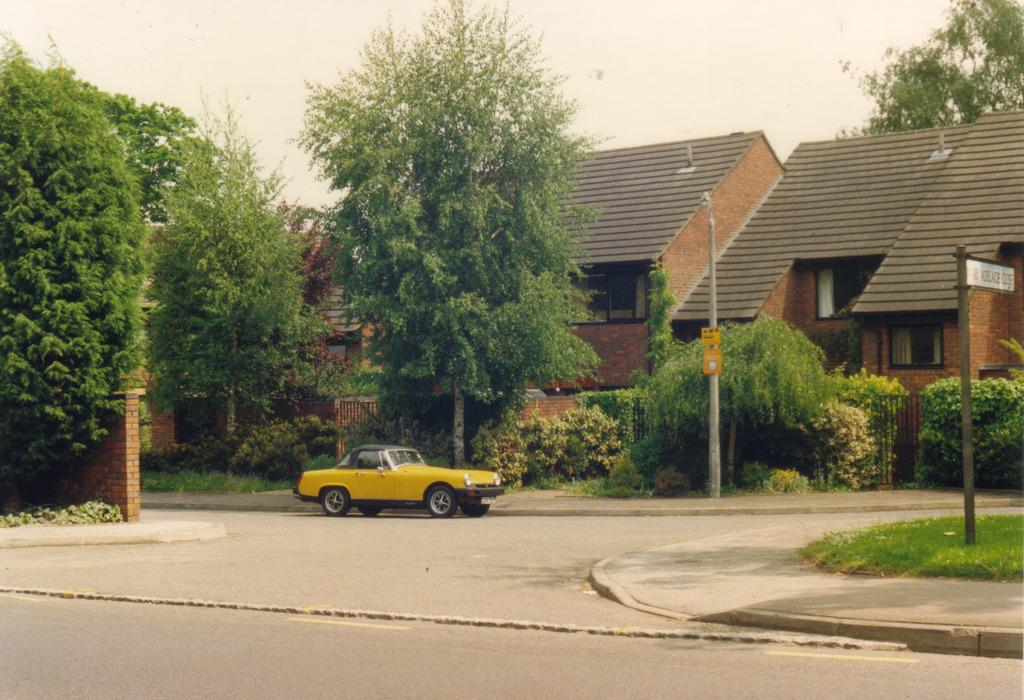What is the main subject of the image? There is a car on the road in the image. What type of vegetation can be seen in the image? Grass, plants, and trees are visible in the image. What structures are present in the image? Poles, boards, a fence, a wall, and houses are in the image. What is visible in the background of the image? The sky is visible in the background of the image. What type of plastic is being used to protect the throat of the person in the image? There is no person or plastic throat protection visible in the image. 